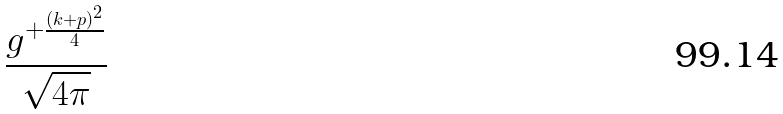Convert formula to latex. <formula><loc_0><loc_0><loc_500><loc_500>\frac { g ^ { + \frac { ( k + p ) ^ { 2 } } { 4 } } } { \sqrt { 4 \pi } }</formula> 